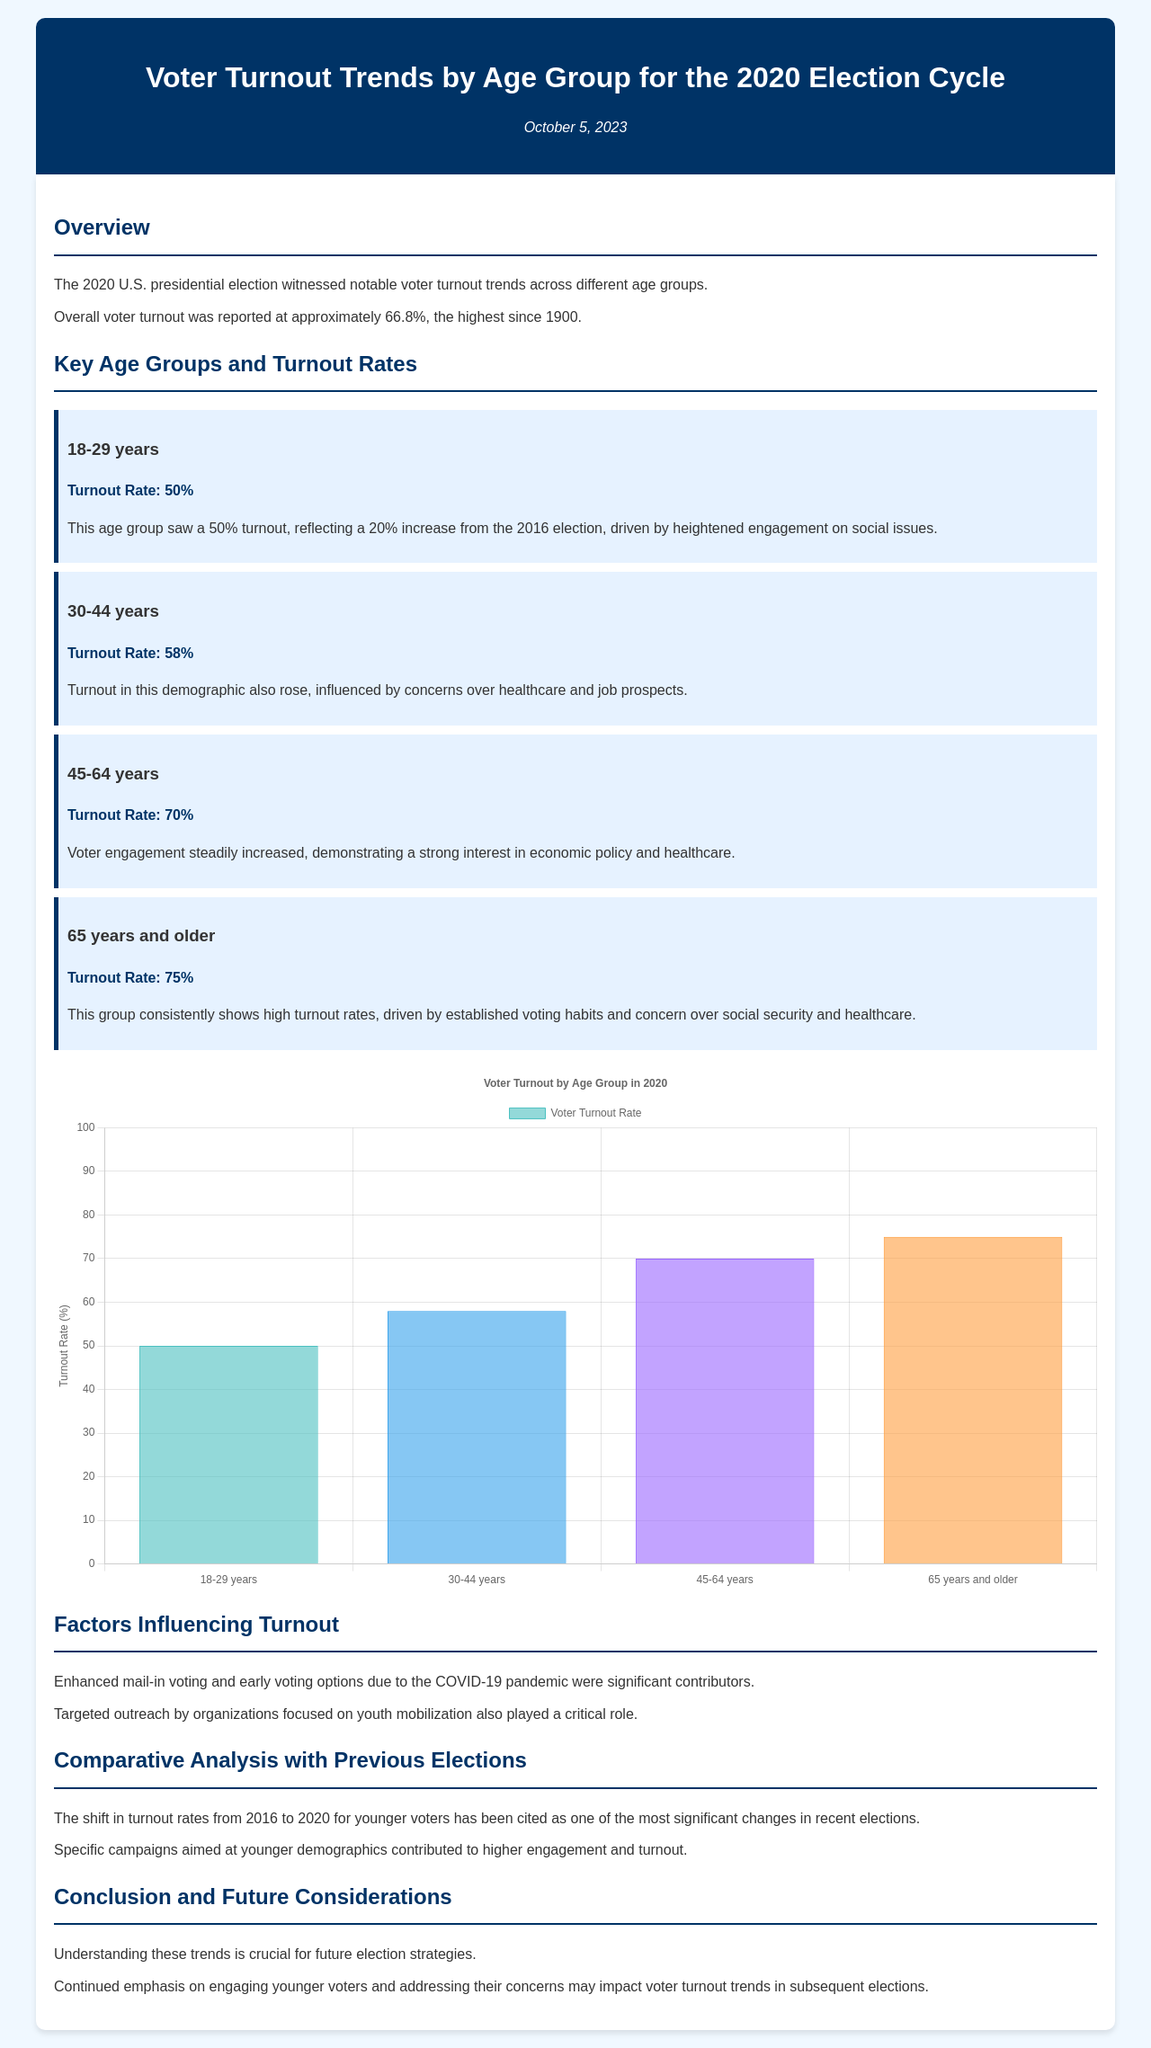What was the overall voter turnout for the 2020 election? The overall voter turnout is reported at approximately 66.8%, as noted in the document.
Answer: 66.8% What was the turnout rate for the 18-29 age group? The turnout rate for the 18-29 age group is mentioned as 50%.
Answer: 50% What age group had the highest turnout rate? The document indicates that the age group with the highest turnout rate is 65 years and older, with a turnout rate of 75%.
Answer: 65 years and older Which factors contributed to increased voter turnout? The document lists enhanced mail-in voting and early voting due to the COVID-19 pandemic as significant contributors to increased voter turnout.
Answer: Enhanced mail-in voting and early voting What was the percentage increase in turnout for the 18-29 age group compared to the 2016 election? The document notes a 20% increase in turnout for the 18-29 age group from the 2016 election.
Answer: 20% What is the main concern driving voter turnout in the 45-64 age group? The document states that economic policy and healthcare are key concerns driving voter engagement in the 45-64 age group.
Answer: Economic policy and healthcare How did voter turnout for younger voters in 2020 compare to previous elections? The document mentions that the shift in turnout rates for younger voters from 2016 to 2020 was one of the most significant changes in recent elections.
Answer: Significant changes What was the date of the document's publication? The publication date of the document is referred to as October 5, 2023.
Answer: October 5, 2023 What role did organizations play in youth voter mobilization? The document states that targeted outreach by organizations aimed at youth mobilization played a critical role in increasing voter turnout.
Answer: Targeted outreach by organizations 